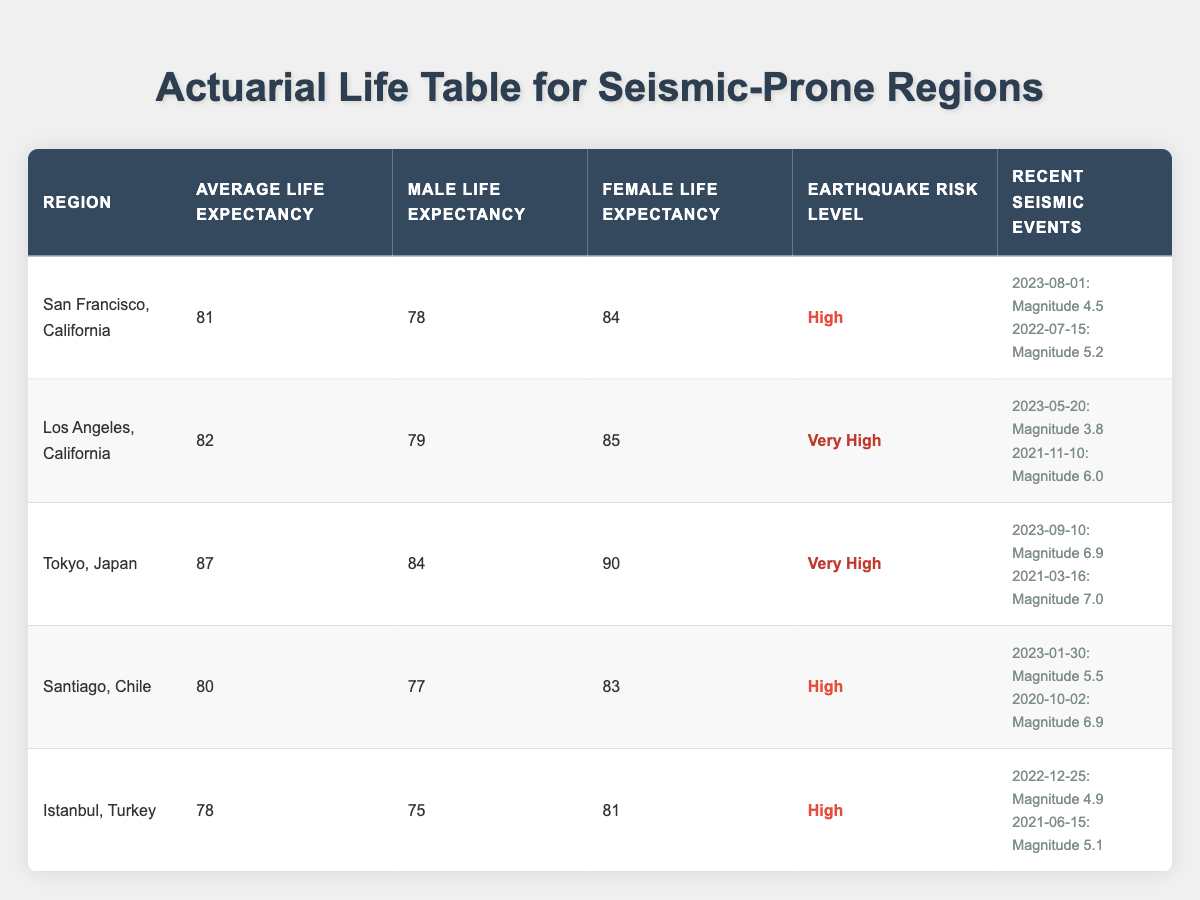What is the average life expectancy in Tokyo, Japan? The table lists the average life expectancy for Tokyo, Japan as 87 years.
Answer: 87 Which region has the highest average life expectancy? By comparing the average life expectancy values listed, Tokyo, Japan has the highest at 87 years.
Answer: Tokyo, Japan What is the male life expectancy in Los Angeles, California? The table indicates that the male life expectancy in Los Angeles, California is 79 years.
Answer: 79 True or False: Istanbul, Turkey has a higher life expectancy for females than males. The life expectancy for females in Istanbul is 81 years, while for males it is 75 years, making the statement true.
Answer: True What is the difference in average life expectancy between San Francisco and Santiago? The average life expectancy in San Francisco is 81 years and in Santiago, it is 80 years. Their difference is 81 - 80 = 1 year.
Answer: 1 Which seismic event in Tokyo had the highest magnitude? The recent seismic events listed for Tokyo include magnitudes of 6.9 and 7.0. The highest magnitude is 7.0 from the event on 2021-03-16.
Answer: 7.0 What is the average life expectancy for male and female combined in Istanbul, Turkey? The male life expectancy is 75 years and female life expectancy is 81 years. To get the combined average, we calculate (75 + 81) / 2 = 78.
Answer: 78 Which region has the lowest average life expectancy? Comparing all the regions, Istanbul, Turkey has the lowest average life expectancy at 78 years.
Answer: Istanbul, Turkey True or False: Los Angeles has a higher earthquake risk level than San Francisco. The risk levels listed show Los Angeles with a risk level of "Very High" and San Francisco with "High," so the statement is true.
Answer: True How many recent seismic events are reported for Santiago, Chile? The table lists two recent seismic events for Santiago, Chile occurring on 2023-01-30 and 2020-10-02.
Answer: 2 